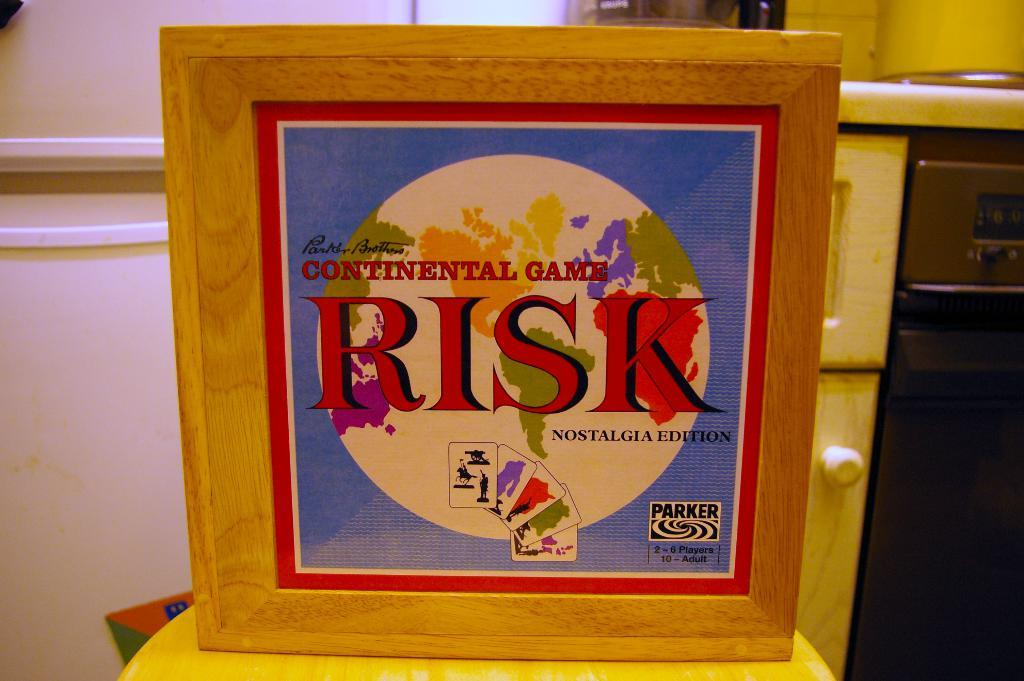<image>
Summarize the visual content of the image. A board game box that says Continental Game Risk. 